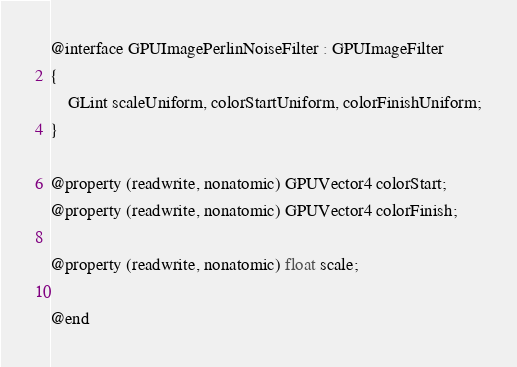Convert code to text. <code><loc_0><loc_0><loc_500><loc_500><_C_>
@interface GPUImagePerlinNoiseFilter : GPUImageFilter
{
    GLint scaleUniform, colorStartUniform, colorFinishUniform;
}

@property (readwrite, nonatomic) GPUVector4 colorStart;
@property (readwrite, nonatomic) GPUVector4 colorFinish;

@property (readwrite, nonatomic) float scale;

@end
</code> 